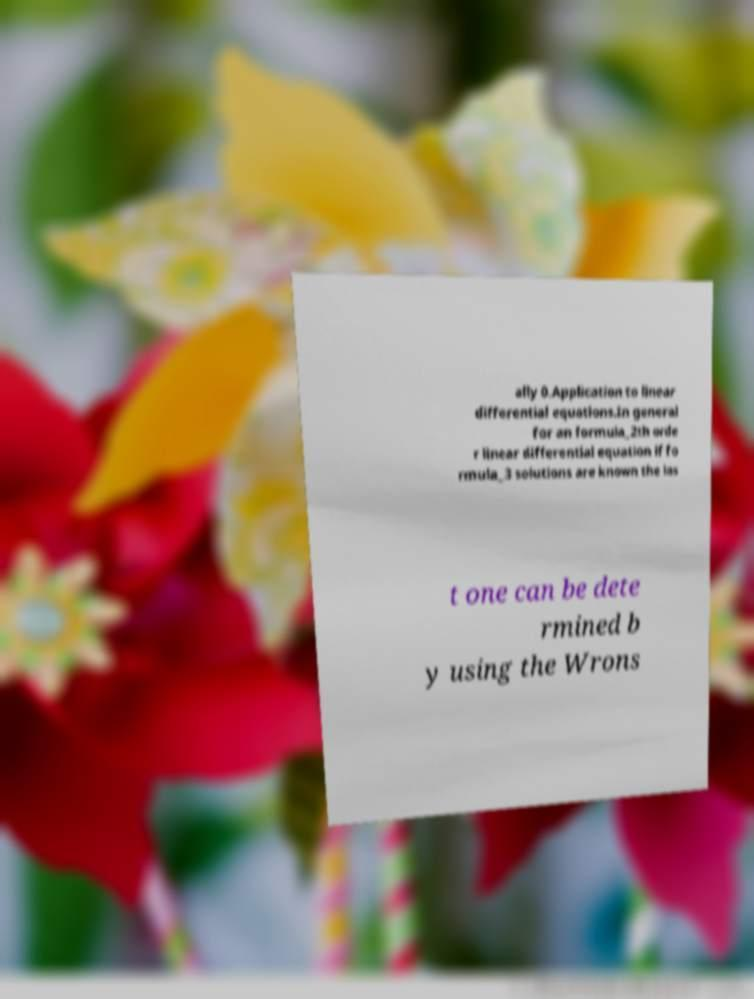What messages or text are displayed in this image? I need them in a readable, typed format. ally 0.Application to linear differential equations.In general for an formula_2th orde r linear differential equation if fo rmula_3 solutions are known the las t one can be dete rmined b y using the Wrons 